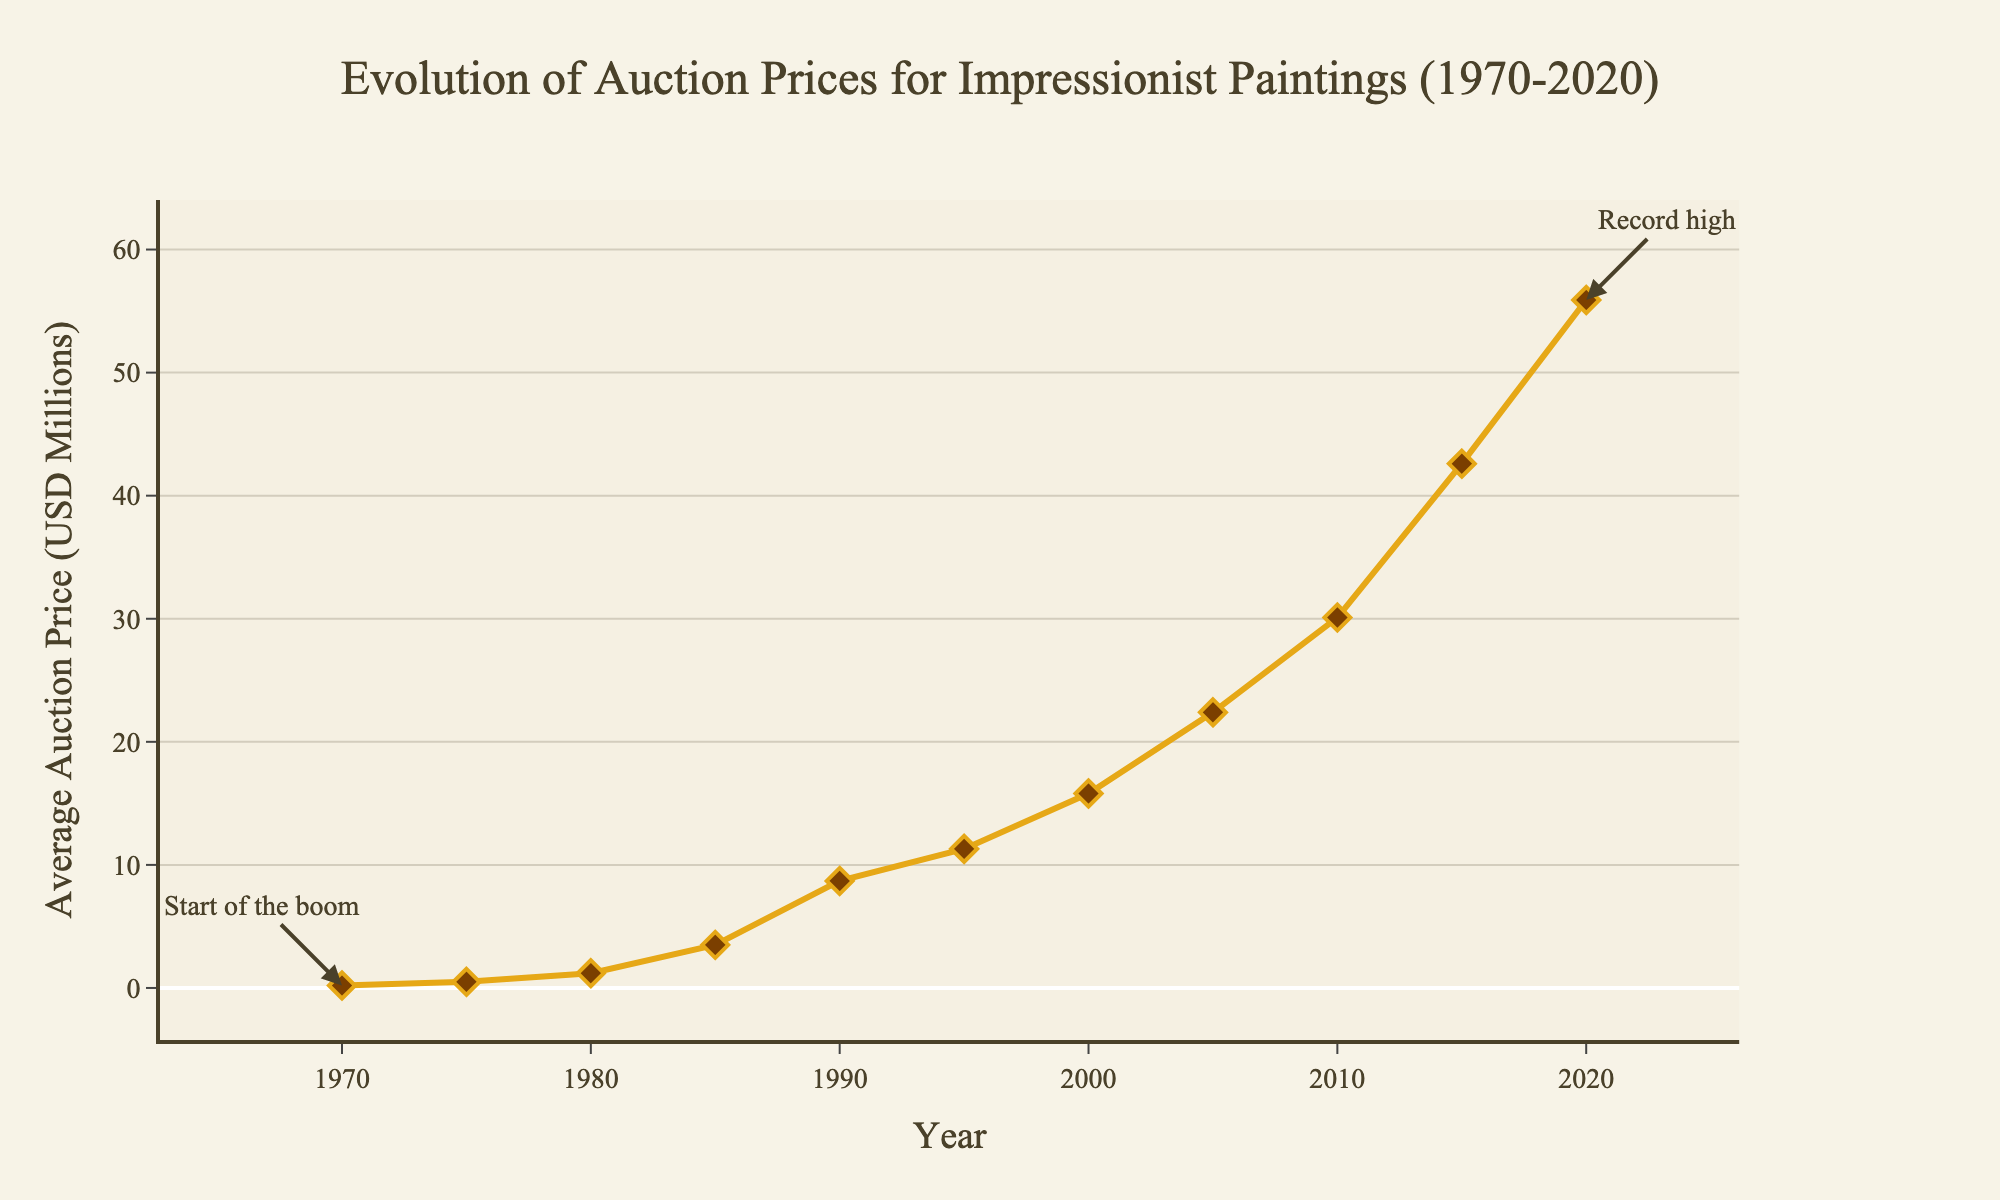What is the trend of the average auction prices for Impressionist paintings from 1970 to 2020? The average auction prices show a general upward trend from 1970 to 2020. This is visualized by the line which rises consistently over the years. Starting from 0.2 million USD in 1970 and reaching 55.9 million USD in 2020.
Answer: Upward trend What was the average auction price for Impressionist paintings in 1990 compared to 2000? In 1990, the average auction price was 8.7 million USD, while in 2000 it was 15.8 million USD. Comparing these two values, the price in 2000 is higher.
Answer: Higher in 2000 What significant changes occurred in average auction prices between 1980 and 1985? The average auction price increased significantly from 1.2 million USD in 1980 to 3.5 million USD in 1985. This shows a significant increase of 2.3 million USD.
Answer: Significant increase What mathematical operations help calculate the increase in average auction price from 2015 to 2020? To find the increase, subtract the 2015 average price (42.6 million USD) from the 2020 average price (55.9 million USD). 55.9 - 42.6 = 13.3 million USD increase.
Answer: Subtraction In which year was the auction price the lowest, and what was that price? The auction price was the lowest in 1970, at 0.2 million USD. This is the starting point of the data series and the lowest data point on the chart.
Answer: 1970, 0.2 million USD From 1985 to 2020, how many times did the average auction price double? Starting from 1985 (3.5 million USD) and doubling each time: 7 million USD (next doubling not in data yet) -> 8.7 in 1990 (no doubling) -> 11.3 (partial double) -> 15.8 in 2000 (not yet). In 2005: 22.4 -> 30.1 -> 42.6 in 2015 (double here) -> and finally 55.9 in 2020 (not quite double 30.1). The price approximately doubled twice, from 3.5 (to above 7) and from 22.4 (to above 42).
Answer: Twice Identify the visual markers used on the line plot to show average auction prices for specific years. The visual markers used are diamond shapes in a brownish color with an outline matching the line's yellow color. These markers are placed on the line at each year represented.
Answer: Diamond markers How does the annotation at the start of the plot help understand the overall trend? The annotation at the 1970 point indicates that it is the "Start of the boom," suggesting that there was a significant growth trend starting around that time. This helps interpret the generally upward trend as a long-term increase in value.
Answer: Indicates growth trend What was the increase in average auction prices from 1975 to 1985? From 1975 (0.5 million USD) to 1985 (3.5 million USD), the increase can be calculated by subtracting the earlier value from the later value, 3.5 - 0.5 = 3 million USD increase.
Answer: 3 million USD 